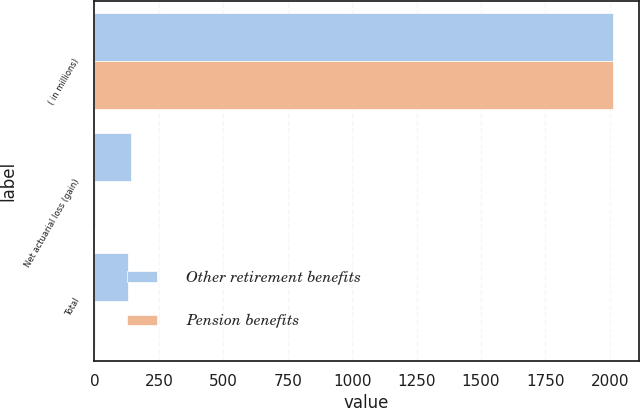<chart> <loc_0><loc_0><loc_500><loc_500><stacked_bar_chart><ecel><fcel>( in millions)<fcel>Net actuarial loss (gain)<fcel>Total<nl><fcel>Other retirement benefits<fcel>2012<fcel>140<fcel>131.6<nl><fcel>Pension benefits<fcel>2012<fcel>2.3<fcel>2.3<nl></chart> 